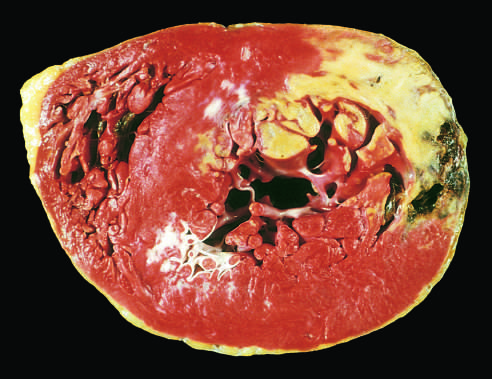what is acute myocardial infarct of the posterolateral left ventricle demonstrate by?
Answer the question using a single word or phrase. A lack of triphenyltetrazolium chloride staining in areas of necrosis 